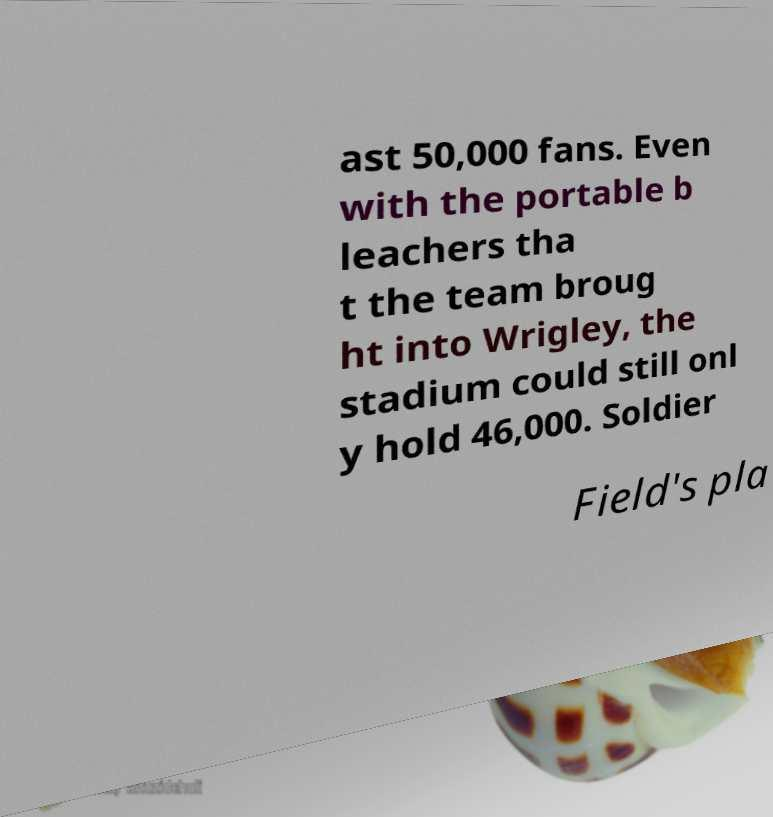Can you read and provide the text displayed in the image?This photo seems to have some interesting text. Can you extract and type it out for me? ast 50,000 fans. Even with the portable b leachers tha t the team broug ht into Wrigley, the stadium could still onl y hold 46,000. Soldier Field's pla 